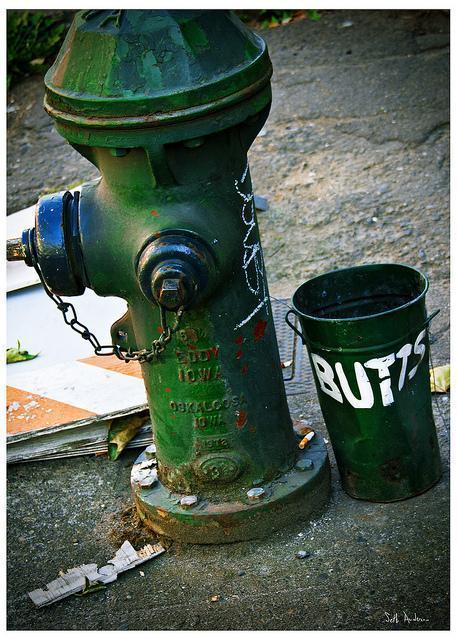How many giraffes are there?
Give a very brief answer. 0. 